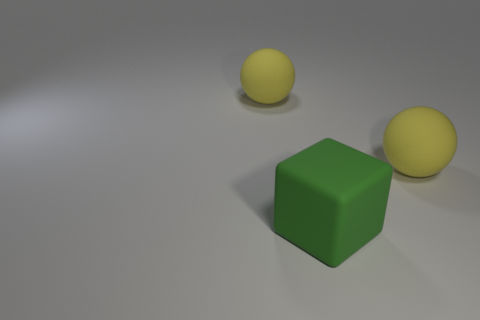What materials do the objects in the image look like they're made of? The objects in the image appear to be made from matte surfaces. The yellow balls have a rubbery texture, suggesting they could be rubber balls, while the green cube has a plastic-like appearance. 